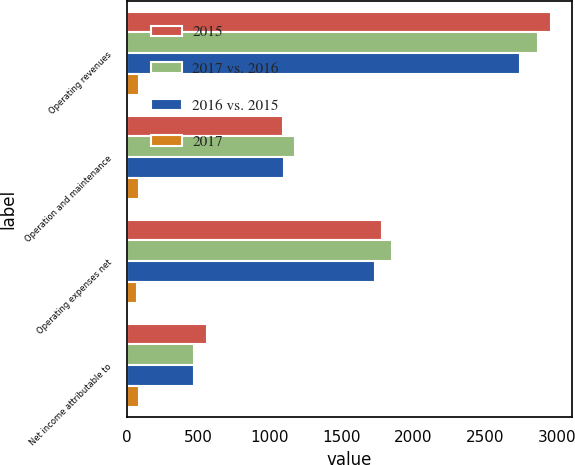Convert chart. <chart><loc_0><loc_0><loc_500><loc_500><stacked_bar_chart><ecel><fcel>Operating revenues<fcel>Operation and maintenance<fcel>Operating expenses net<fcel>Net income attributable to<nl><fcel>2015<fcel>2958<fcel>1091<fcel>1781<fcel>559<nl><fcel>2017 vs. 2016<fcel>2871<fcel>1176<fcel>1852<fcel>472<nl><fcel>2016 vs. 2015<fcel>2743<fcel>1095<fcel>1732<fcel>473<nl><fcel>2017<fcel>87<fcel>85<fcel>71<fcel>87<nl></chart> 